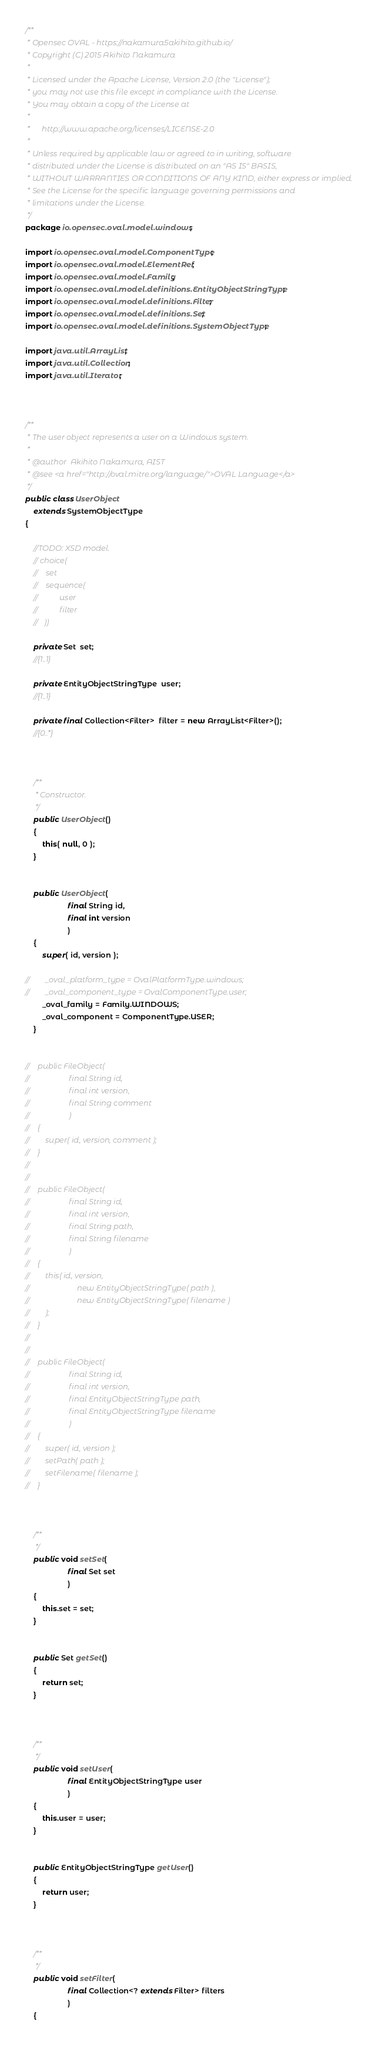Convert code to text. <code><loc_0><loc_0><loc_500><loc_500><_Java_>/**
 * Opensec OVAL - https://nakamura5akihito.github.io/
 * Copyright (C) 2015 Akihito Nakamura
 *
 * Licensed under the Apache License, Version 2.0 (the "License");
 * you may not use this file except in compliance with the License.
 * You may obtain a copy of the License at
 *
 *      http://www.apache.org/licenses/LICENSE-2.0
 *
 * Unless required by applicable law or agreed to in writing, software
 * distributed under the License is distributed on an "AS IS" BASIS,
 * WITHOUT WARRANTIES OR CONDITIONS OF ANY KIND, either express or implied.
 * See the License for the specific language governing permissions and
 * limitations under the License.
 */
package io.opensec.oval.model.windows;

import io.opensec.oval.model.ComponentType;
import io.opensec.oval.model.ElementRef;
import io.opensec.oval.model.Family;
import io.opensec.oval.model.definitions.EntityObjectStringType;
import io.opensec.oval.model.definitions.Filter;
import io.opensec.oval.model.definitions.Set;
import io.opensec.oval.model.definitions.SystemObjectType;

import java.util.ArrayList;
import java.util.Collection;
import java.util.Iterator;



/**
 * The user object represents a user on a Windows system.
 *
 * @author  Akihito Nakamura, AIST
 * @see <a href="http://oval.mitre.org/language/">OVAL Language</a>
 */
public class UserObject
    extends SystemObjectType
{

    //TODO: XSD model.
	// choice(
	//    set
    //    sequence(
    //           user
    //           filter
    //   ))

    private Set  set;
    //{1..1}

    private EntityObjectStringType  user;
    //{1..1}

    private final Collection<Filter>  filter = new ArrayList<Filter>();
    //{0..*}



    /**
     * Constructor.
     */
    public UserObject()
    {
        this( null, 0 );
    }


    public UserObject(
                    final String id,
                    final int version
                    )
    {
        super( id, version );

//        _oval_platform_type = OvalPlatformType.windows;
//        _oval_component_type = OvalComponentType.user;
        _oval_family = Family.WINDOWS;
        _oval_component = ComponentType.USER;
    }


//    public FileObject(
//                    final String id,
//                    final int version,
//                    final String comment
//                    )
//    {
//        super( id, version, comment );
//    }
//
//
//    public FileObject(
//                    final String id,
//                    final int version,
//                    final String path,
//                    final String filename
//                    )
//    {
//        this( id, version,
//                        new EntityObjectStringType( path ),
//                        new EntityObjectStringType( filename )
//        );
//    }
//
//
//    public FileObject(
//                    final String id,
//                    final int version,
//                    final EntityObjectStringType path,
//                    final EntityObjectStringType filename
//                    )
//    {
//        super( id, version );
//        setPath( path );
//        setFilename( filename );
//    }



    /**
     */
    public void setSet(
                    final Set set
                    )
    {
        this.set = set;
    }


    public Set getSet()
    {
        return set;
    }



    /**
     */
    public void setUser(
                    final EntityObjectStringType user
                    )
    {
        this.user = user;
    }


    public EntityObjectStringType getUser()
    {
        return user;
    }



    /**
     */
    public void setFilter(
                    final Collection<? extends Filter> filters
                    )
    {</code> 